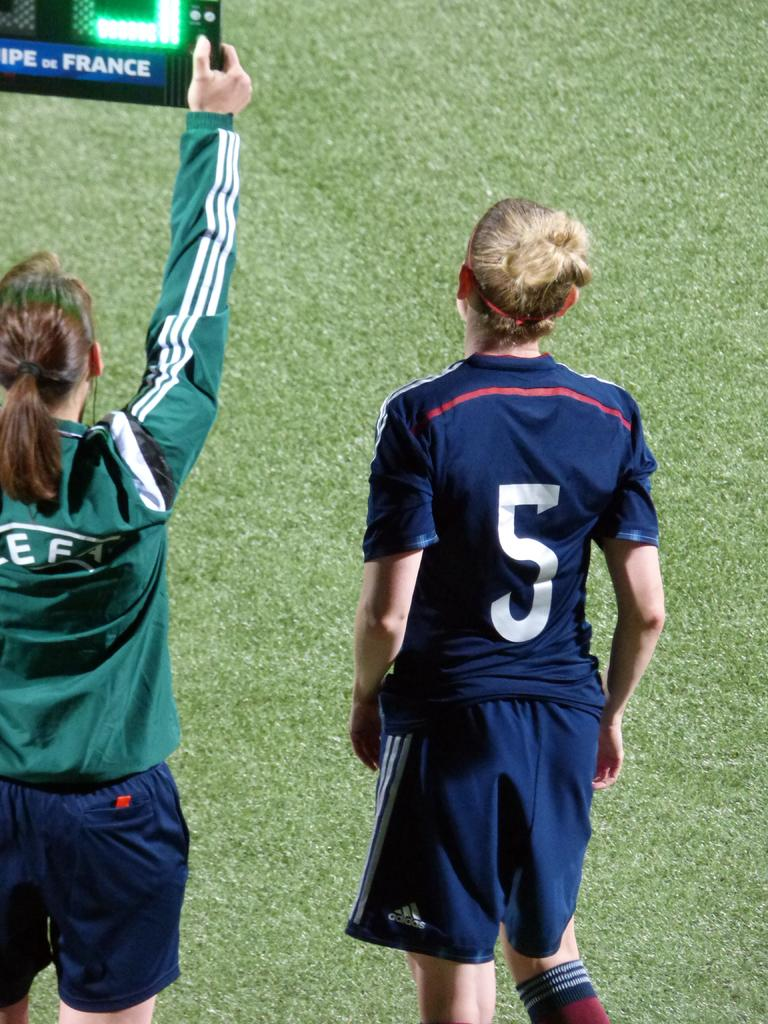Provide a one-sentence caption for the provided image. two players in teeshirts and shorts showing off a sign for france. 